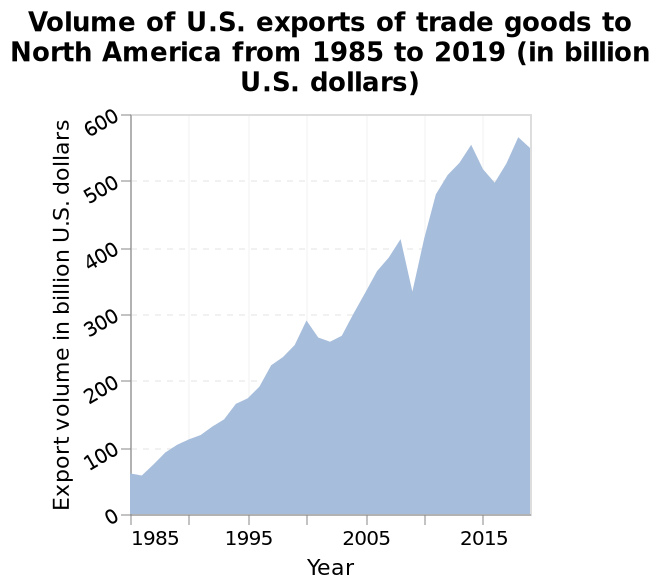<image>
Is the export trend of trade goods to North America stable or volatile?  The export trend of trade goods to North America is volatile and goes up and down. What is the range of the y-axis on the area diagram?  The range of the y-axis on the area diagram is from 0 to 600 billion U.S. dollars. When did the dramatic increase in exports of trade goods to North America begin?  The dramatic increase in exports of trade goods to North America began in 1985. What is the title of the area diagram?  The title of the area diagram is "Volume of U.S. exports of trade goods to North America from 1985 to 2019 (in billion U.S. dollars)." 